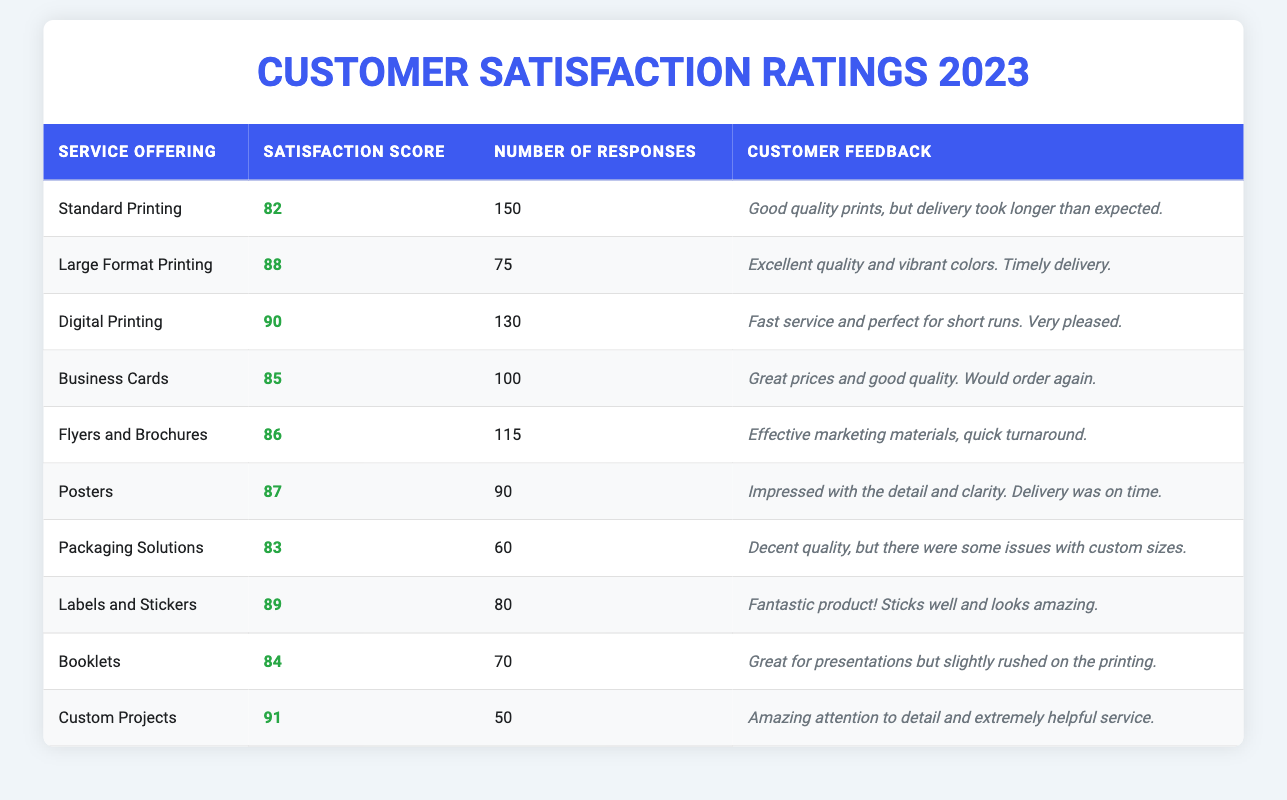What is the satisfaction score for Digital Printing? The table shows that the satisfaction score for Digital Printing is 90.
Answer: 90 How many responses were received for Large Format Printing? According to the table, there were 75 responses received for Large Format Printing.
Answer: 75 Which service offering has the highest satisfaction score? The table indicates that the service offering with the highest satisfaction score is Custom Projects with a score of 91.
Answer: Custom Projects What is the average satisfaction score across all service offerings? To find the average, sum the satisfaction scores: (82 + 88 + 90 + 85 + 86 + 87 + 83 + 89 + 84 + 91) =  885. There are 10 service offerings, so the average is 885 / 10 = 88.5.
Answer: 88.5 Is the satisfaction score for Business Cards above 80? The table shows that the satisfaction score for Business Cards is 85, which is indeed above 80.
Answer: Yes How many responses did the service offering with the lowest satisfaction score receive? The service offering with the lowest satisfaction score is Packaging Solutions with a score of 83. The number of responses for Packaging Solutions is 60.
Answer: 60 What is the difference in satisfaction scores between Digital Printing and Business Cards? The satisfaction score for Digital Printing is 90 and for Business Cards is 85. The difference is 90 - 85 = 5.
Answer: 5 Which service offerings have a satisfaction score greater than 85? The service offerings with satisfaction scores greater than 85 are Large Format Printing (88), Digital Printing (90), Flyers and Brochures (86), Posters (87), Labels and Stickers (89), and Custom Projects (91).
Answer: 6 service offerings What percentage of responses came from customers for Standard Printing? The total number of responses across all services is 150 + 75 + 130 + 100 + 115 + 90 + 60 + 80 + 70 + 50 = 1,000. The responses for Standard Printing are 150. The percentage is (150 / 1000) * 100 = 15%.
Answer: 15% Is the customer feedback for Labels and Stickers positive? The feedback states, "Fantastic product! Sticks well and looks amazing," which indicates positive customer sentiment.
Answer: Yes 